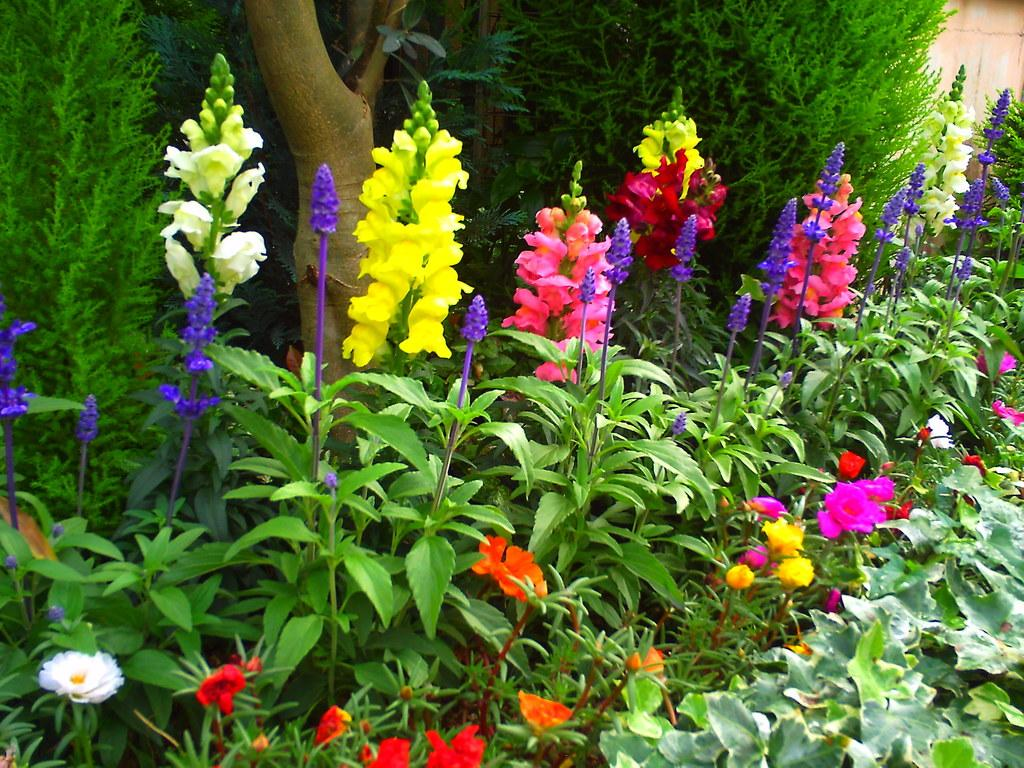What is the main subject in the center of the image? There are plants with flowers in the center of the image. What can be seen in the background of the image? There are bushes and trees in the background of the image. Where is the river located in the image? There is no river present in the image. What type of doll can be seen playing with the flowers in the image? There is no doll present in the image. 